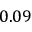Convert formula to latex. <formula><loc_0><loc_0><loc_500><loc_500>0 . 0 9</formula> 